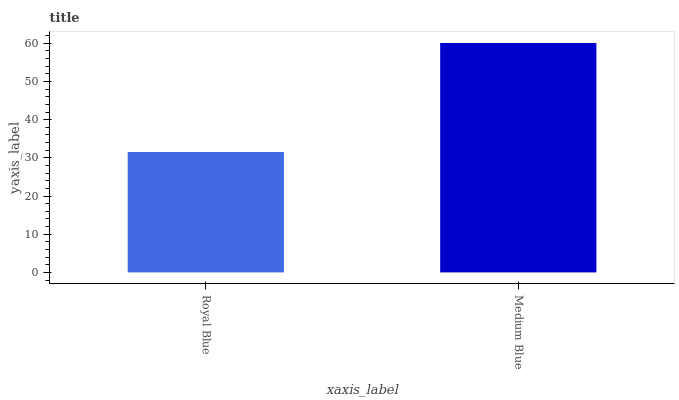Is Royal Blue the minimum?
Answer yes or no. Yes. Is Medium Blue the maximum?
Answer yes or no. Yes. Is Medium Blue the minimum?
Answer yes or no. No. Is Medium Blue greater than Royal Blue?
Answer yes or no. Yes. Is Royal Blue less than Medium Blue?
Answer yes or no. Yes. Is Royal Blue greater than Medium Blue?
Answer yes or no. No. Is Medium Blue less than Royal Blue?
Answer yes or no. No. Is Medium Blue the high median?
Answer yes or no. Yes. Is Royal Blue the low median?
Answer yes or no. Yes. Is Royal Blue the high median?
Answer yes or no. No. Is Medium Blue the low median?
Answer yes or no. No. 